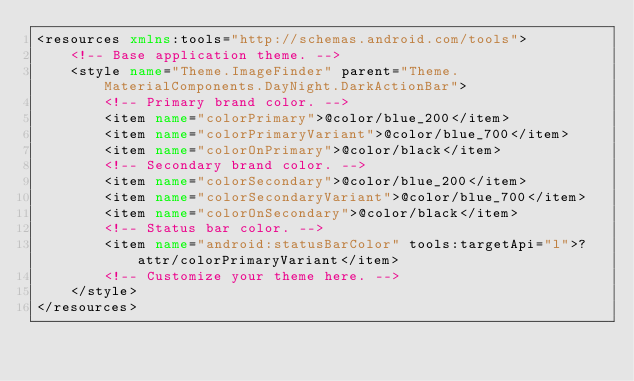Convert code to text. <code><loc_0><loc_0><loc_500><loc_500><_XML_><resources xmlns:tools="http://schemas.android.com/tools">
    <!-- Base application theme. -->
    <style name="Theme.ImageFinder" parent="Theme.MaterialComponents.DayNight.DarkActionBar">
        <!-- Primary brand color. -->
        <item name="colorPrimary">@color/blue_200</item>
        <item name="colorPrimaryVariant">@color/blue_700</item>
        <item name="colorOnPrimary">@color/black</item>
        <!-- Secondary brand color. -->
        <item name="colorSecondary">@color/blue_200</item>
        <item name="colorSecondaryVariant">@color/blue_700</item>
        <item name="colorOnSecondary">@color/black</item>
        <!-- Status bar color. -->
        <item name="android:statusBarColor" tools:targetApi="l">?attr/colorPrimaryVariant</item>
        <!-- Customize your theme here. -->
    </style>
</resources></code> 